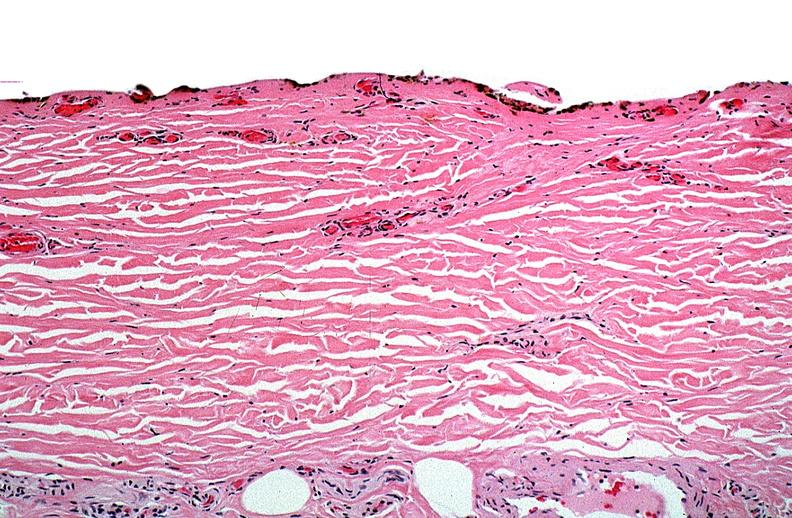what does this image show?
Answer the question using a single word or phrase. Thermal burned skin 